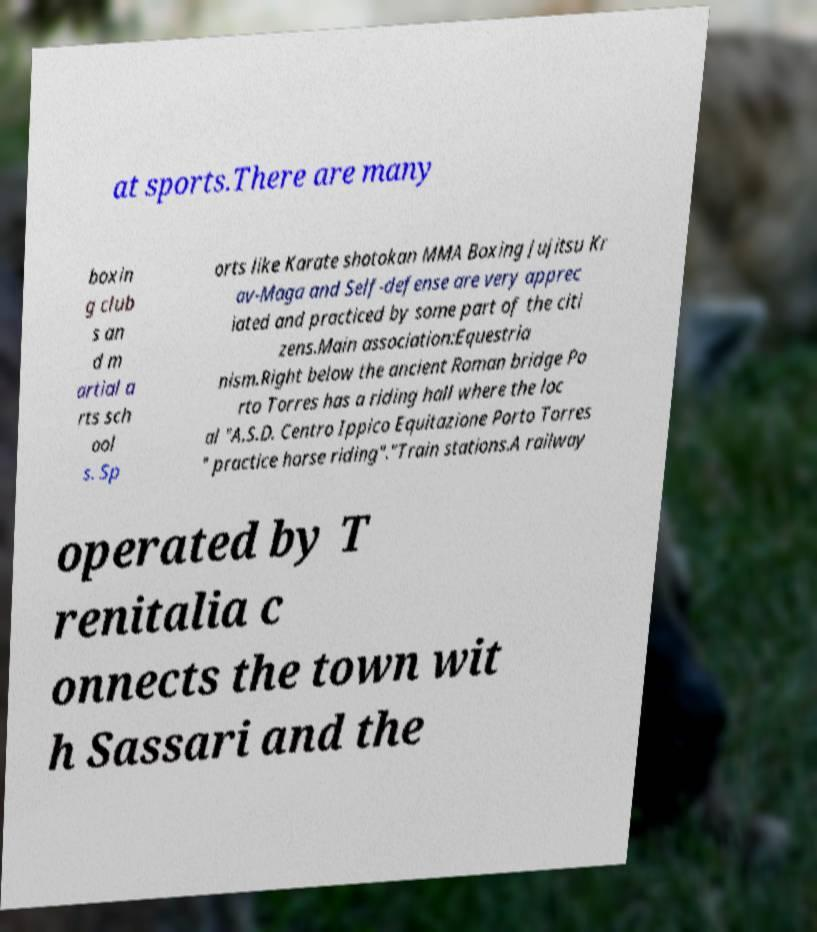Please identify and transcribe the text found in this image. at sports.There are many boxin g club s an d m artial a rts sch ool s. Sp orts like Karate shotokan MMA Boxing Jujitsu Kr av-Maga and Self-defense are very apprec iated and practiced by some part of the citi zens.Main association:Equestria nism.Right below the ancient Roman bridge Po rto Torres has a riding hall where the loc al "A.S.D. Centro Ippico Equitazione Porto Torres " practice horse riding"."Train stations.A railway operated by T renitalia c onnects the town wit h Sassari and the 